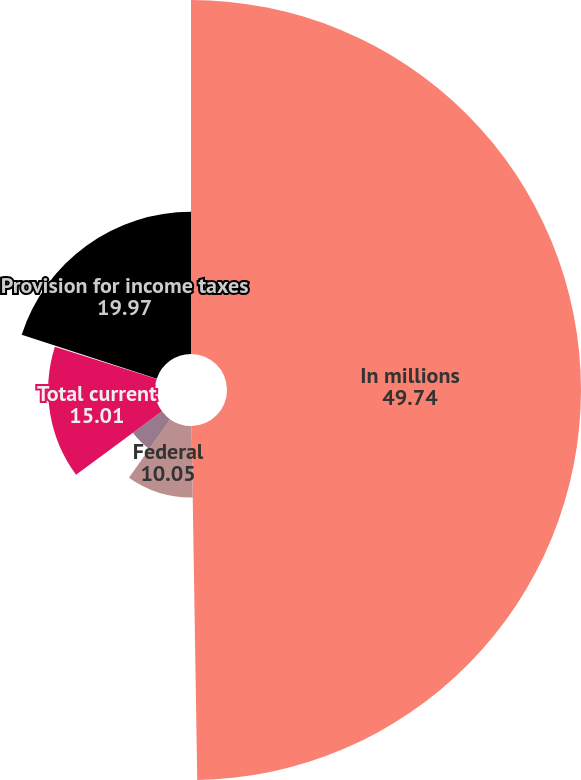Convert chart to OTSL. <chart><loc_0><loc_0><loc_500><loc_500><pie_chart><fcel>In millions<fcel>Federal<fcel>State<fcel>Total current<fcel>Total deferred<fcel>Provision for income taxes<nl><fcel>49.74%<fcel>10.05%<fcel>5.09%<fcel>15.01%<fcel>0.13%<fcel>19.97%<nl></chart> 